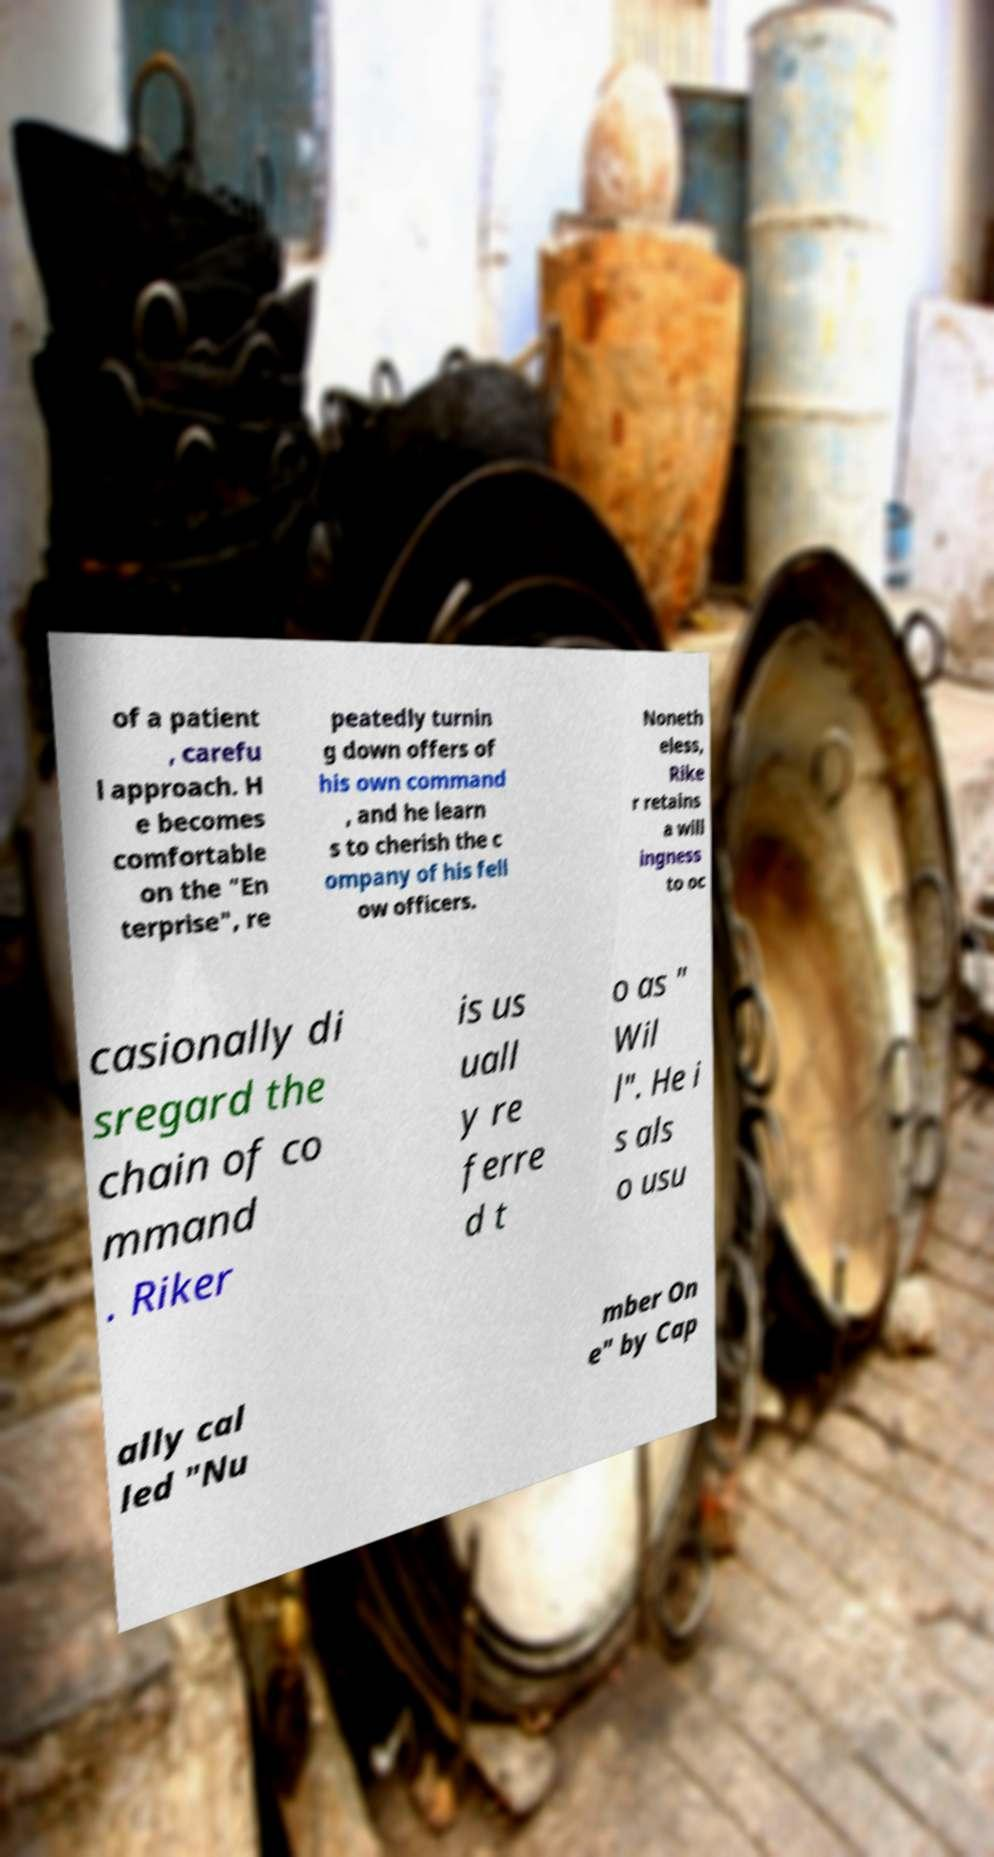Can you accurately transcribe the text from the provided image for me? of a patient , carefu l approach. H e becomes comfortable on the "En terprise", re peatedly turnin g down offers of his own command , and he learn s to cherish the c ompany of his fell ow officers. Noneth eless, Rike r retains a will ingness to oc casionally di sregard the chain of co mmand . Riker is us uall y re ferre d t o as " Wil l". He i s als o usu ally cal led "Nu mber On e" by Cap 